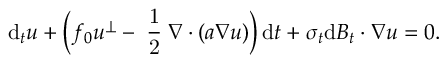Convert formula to latex. <formula><loc_0><loc_0><loc_500><loc_500>d _ { t } u + \left ( f _ { 0 } u ^ { \perp } - \frac { 1 } { 2 } \nabla \cdot ( a \nabla u ) \right ) \, d t + \sigma _ { t } d B _ { t } \cdot \nabla u = 0 .</formula> 